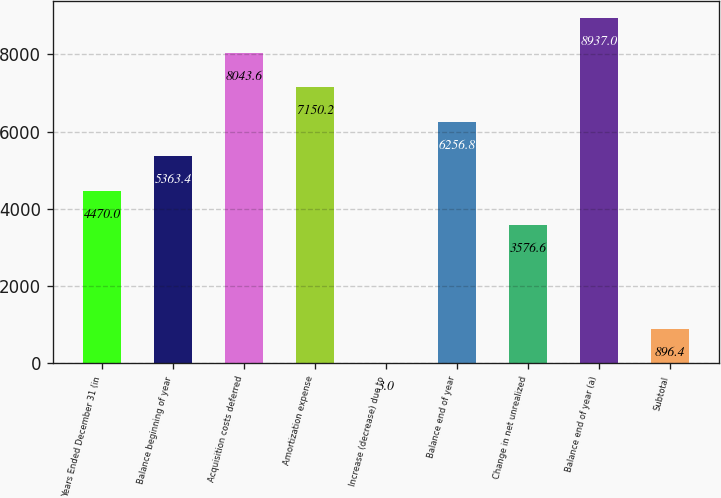Convert chart. <chart><loc_0><loc_0><loc_500><loc_500><bar_chart><fcel>Years Ended December 31 (in<fcel>Balance beginning of year<fcel>Acquisition costs deferred<fcel>Amortization expense<fcel>Increase (decrease) due to<fcel>Balance end of year<fcel>Change in net unrealized<fcel>Balance end of year (a)<fcel>Subtotal<nl><fcel>4470<fcel>5363.4<fcel>8043.6<fcel>7150.2<fcel>3<fcel>6256.8<fcel>3576.6<fcel>8937<fcel>896.4<nl></chart> 